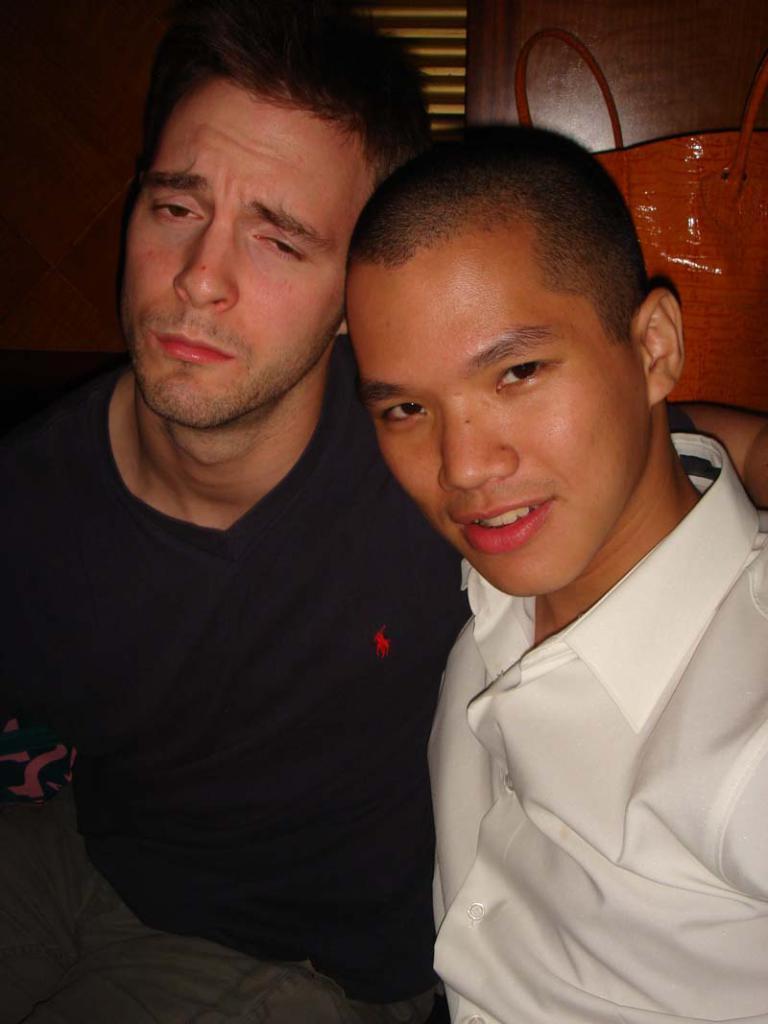Can you describe this image briefly? In this age I can see two men. The man who is sitting on the right side is wearing white color shirt. The man who is sitting on the left side is wearing black color t-shirt. Both are giving pose for the picture. At the back of them I can see a bag. 